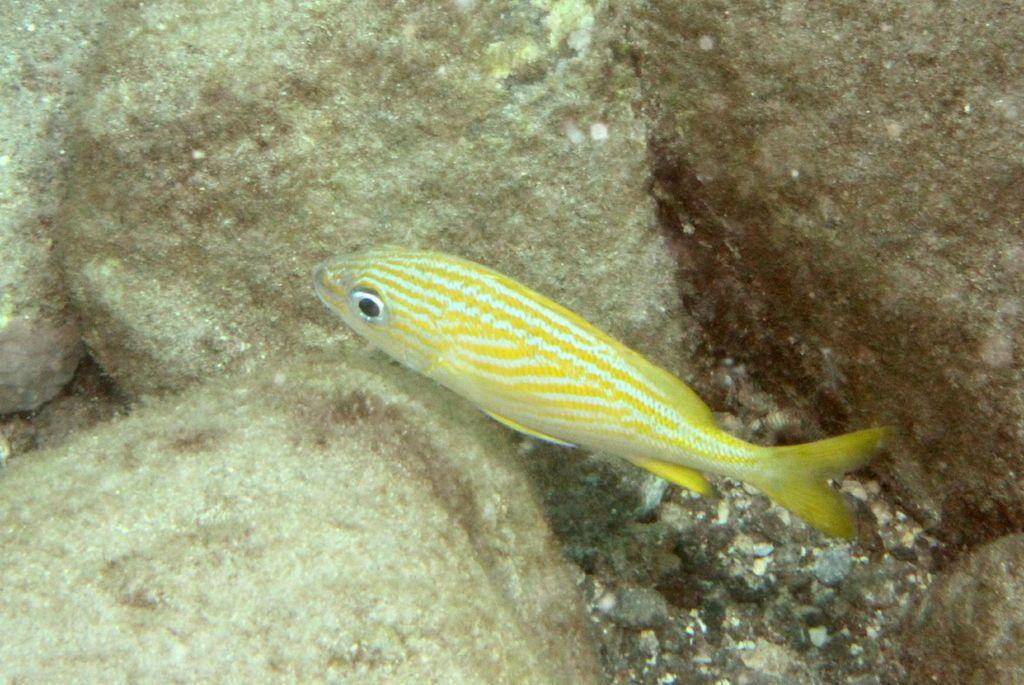What type of animal is in the image? There is a yellow color fish in the image. Where is the fish located? The fish is in the sea water. What else can be seen in the image besides the fish? There are rocks visible in the image. How many passengers are on the fish in the image? There are no passengers on the fish in the image, as it is a fish in the sea water and not a mode of transportation. 